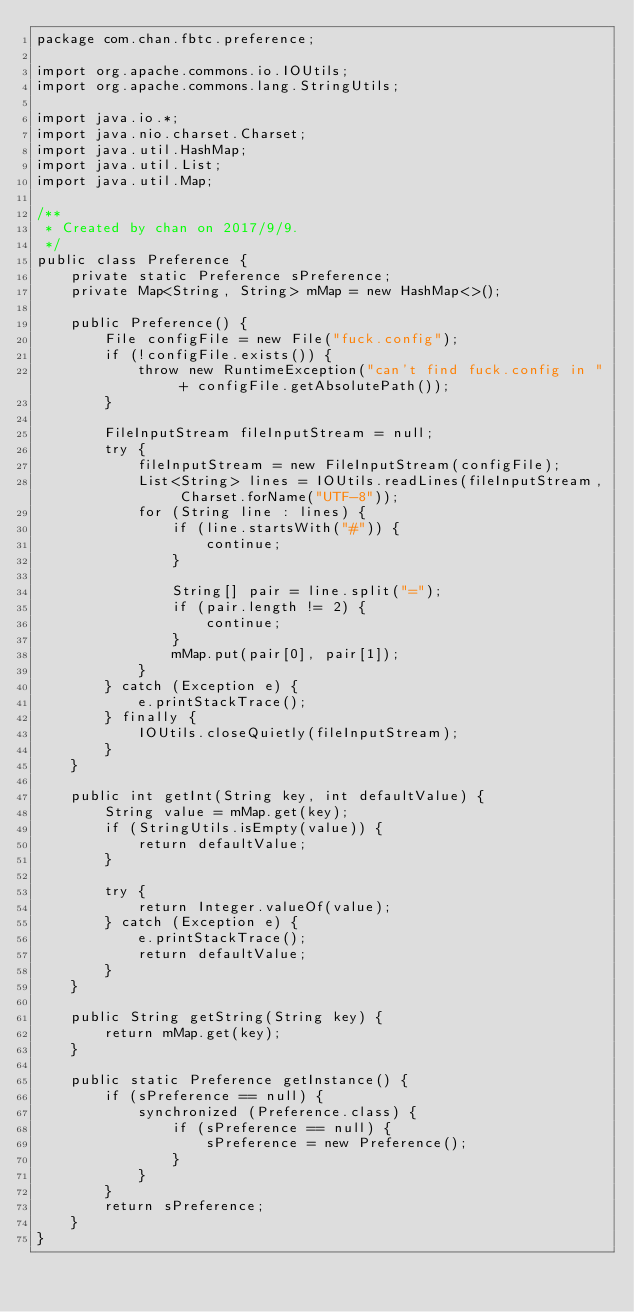Convert code to text. <code><loc_0><loc_0><loc_500><loc_500><_Java_>package com.chan.fbtc.preference;

import org.apache.commons.io.IOUtils;
import org.apache.commons.lang.StringUtils;

import java.io.*;
import java.nio.charset.Charset;
import java.util.HashMap;
import java.util.List;
import java.util.Map;

/**
 * Created by chan on 2017/9/9.
 */
public class Preference {
    private static Preference sPreference;
    private Map<String, String> mMap = new HashMap<>();

    public Preference() {
        File configFile = new File("fuck.config");
        if (!configFile.exists()) {
            throw new RuntimeException("can't find fuck.config in " + configFile.getAbsolutePath());
        }

        FileInputStream fileInputStream = null;
        try {
            fileInputStream = new FileInputStream(configFile);
            List<String> lines = IOUtils.readLines(fileInputStream, Charset.forName("UTF-8"));
            for (String line : lines) {
                if (line.startsWith("#")) {
                    continue;
                }

                String[] pair = line.split("=");
                if (pair.length != 2) {
                    continue;
                }
                mMap.put(pair[0], pair[1]);
            }
        } catch (Exception e) {
            e.printStackTrace();
        } finally {
            IOUtils.closeQuietly(fileInputStream);
        }
    }

    public int getInt(String key, int defaultValue) {
        String value = mMap.get(key);
        if (StringUtils.isEmpty(value)) {
            return defaultValue;
        }

        try {
            return Integer.valueOf(value);
        } catch (Exception e) {
            e.printStackTrace();
            return defaultValue;
        }
    }

    public String getString(String key) {
        return mMap.get(key);
    }

    public static Preference getInstance() {
        if (sPreference == null) {
            synchronized (Preference.class) {
                if (sPreference == null) {
                    sPreference = new Preference();
                }
            }
        }
        return sPreference;
    }
}
</code> 